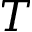Convert formula to latex. <formula><loc_0><loc_0><loc_500><loc_500>T</formula> 